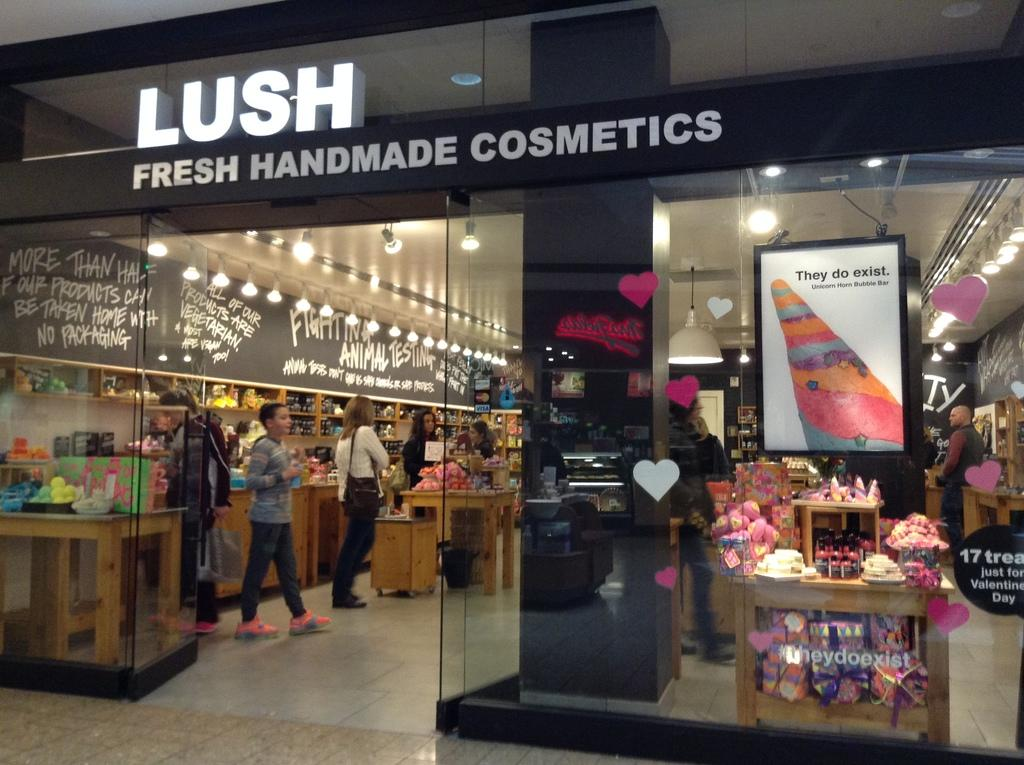<image>
Describe the image concisely. Customers are shopping in a beauty store named Lush. 